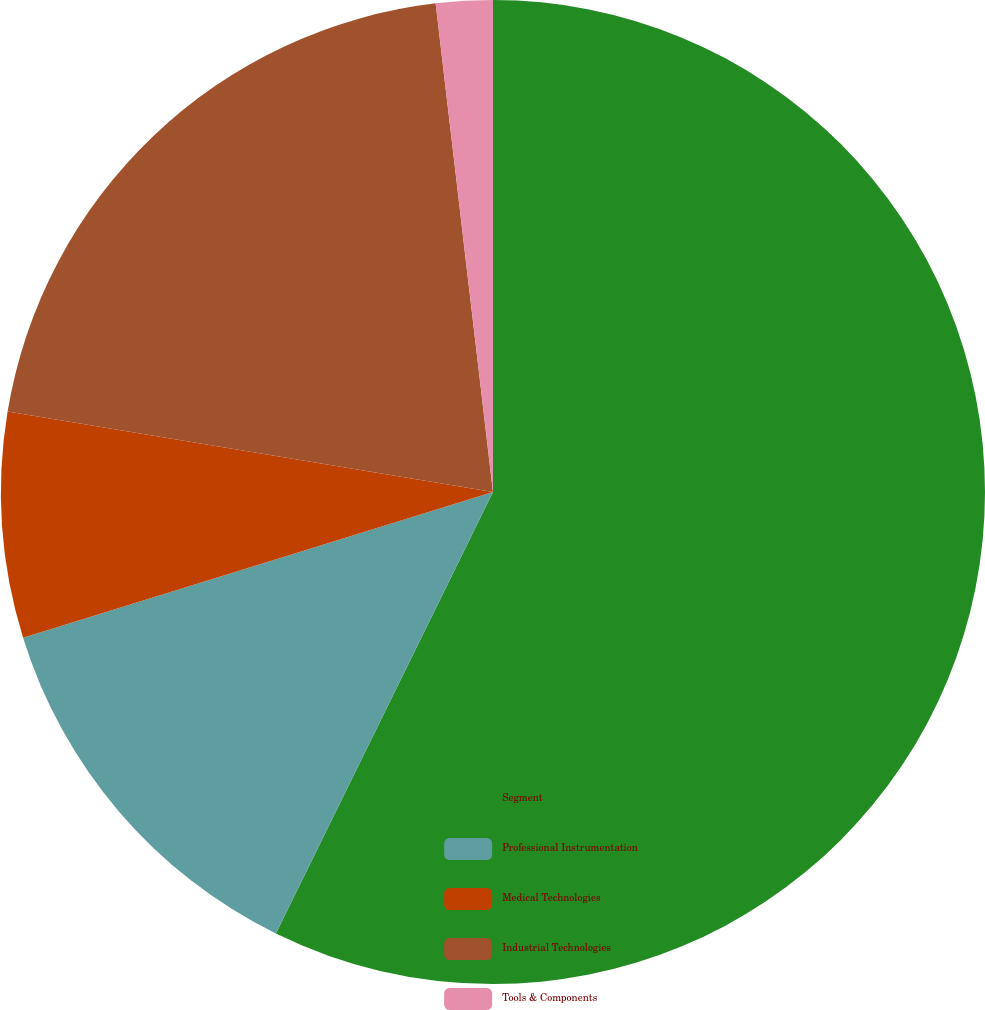Convert chart to OTSL. <chart><loc_0><loc_0><loc_500><loc_500><pie_chart><fcel>Segment<fcel>Professional Instrumentation<fcel>Medical Technologies<fcel>Industrial Technologies<fcel>Tools & Components<nl><fcel>57.28%<fcel>12.94%<fcel>7.4%<fcel>20.53%<fcel>1.86%<nl></chart> 